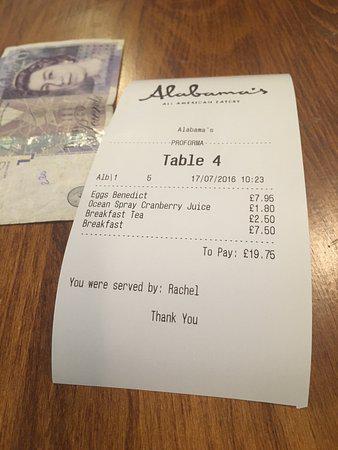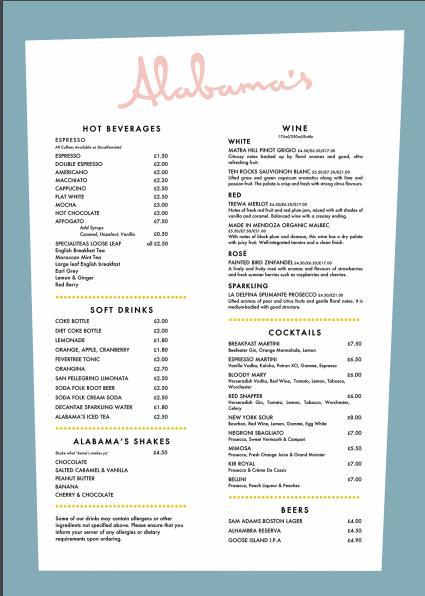The first image is the image on the left, the second image is the image on the right. Evaluate the accuracy of this statement regarding the images: "There are exactly two menus.". Is it true? Answer yes or no. No. The first image is the image on the left, the second image is the image on the right. Analyze the images presented: Is the assertion "A piece of restaurant related paper sits on a wooden surface in one of the images." valid? Answer yes or no. Yes. 